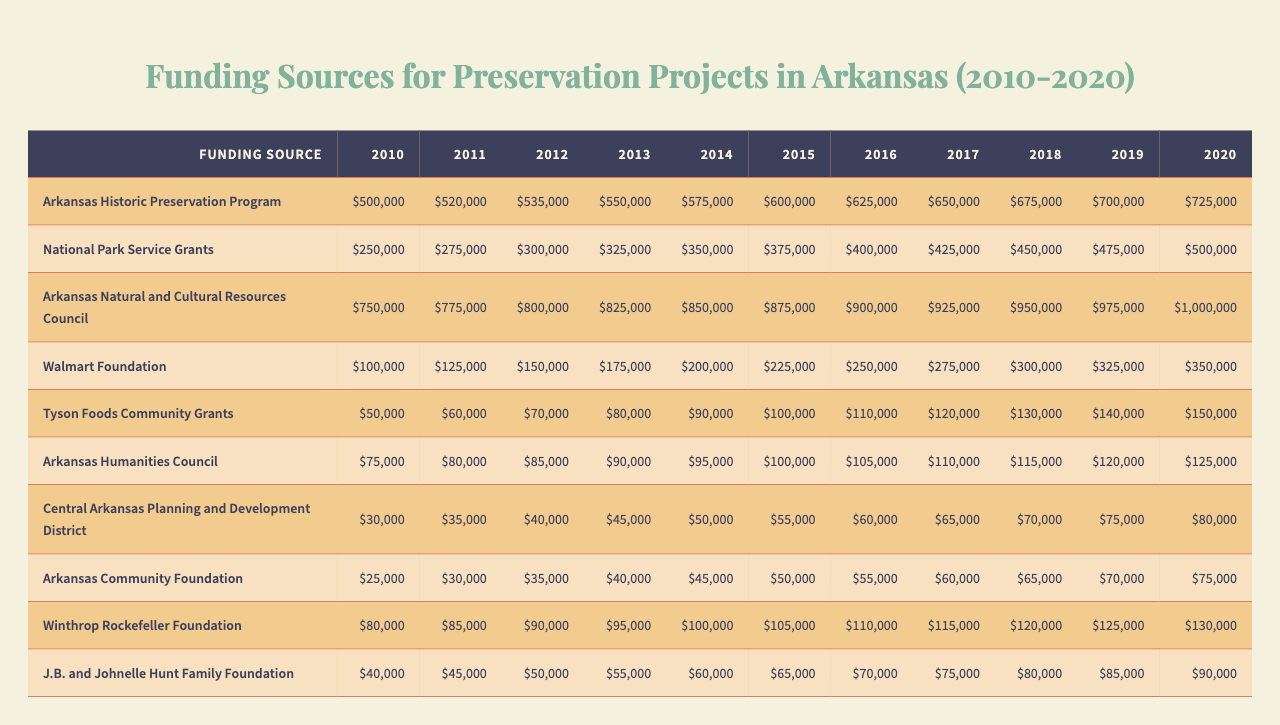What was the total funding from the Arkansas Natural and Cultural Resources Council in 2015? The funding amount from the Arkansas Natural and Cultural Resources Council for the year 2015 is listed in the table as $875,000.
Answer: $875,000 Which funding source had the highest amount in 2020? In 2020, the funding from the Arkansas Natural and Cultural Resources Council was the highest, with an amount of $1,000,000.
Answer: Arkansas Natural and Cultural Resources Council What is the difference in funding from the Walmart Foundation between 2010 and 2020? In 2010, the Walmart Foundation provided $100,000, and in 2020 it provided $350,000. The difference is $350,000 - $100,000 = $250,000.
Answer: $250,000 What was the average funding from the Arkansas Historic Preservation Program over the years 2010 to 2020? The total funding from the Arkansas Historic Preservation Program from 2010 to 2020 is 500,000 + 520,000 + 535,000 + 550,000 + 575,000 + 600,000 + 625,000 + 650,000 + 675,000 + 700,000 + 725,000 = $6,655,000. There are 11 years, so the average is $6,655,000 / 11 = $605,000.
Answer: $605,000 Did the funding from Tyson Foods Community Grants increase every year from 2010 to 2020? Yes, the table shows that the funding from Tyson Foods Community Grants started at $50,000 in 2010 and increased by $10,000 each year until reaching $150,000 in 2020.
Answer: Yes What was the total funding received from all sources in 2018? To find the total funding from all sources in 2018, we add the amounts: Arkansas Historic Preservation Program ($675,000) + National Park Service Grants ($450,000) + Arkansas Natural and Cultural Resources Council ($950,000) + Walmart Foundation ($300,000) + Tyson Foods Community Grants ($130,000) + Arkansas Humanities Council ($115,000) + Central Arkansas Planning and Development District ($70,000) + Arkansas Community Foundation ($65,000) + Winthrop Rockefeller Foundation ($120,000) + J.B. and Johnelle Hunt Family Foundation ($80,000) = $2,985,000.
Answer: $2,985,000 What years did the funding from the Central Arkansas Planning and Development District exceed $50,000? The amounts from the Central Arkansas Planning and Development District were $30,000 in 2010, $35,000 in 2011, $40,000 in 2012, $45,000 in 2013, $50,000 in 2014, $55,000 in 2015, $60,000 in 2016, $65,000 in 2017, $70,000 in 2018, $75,000 in 2019, and $80,000 in 2020. The years in which it exceeded $50,000 are 2015, 2016, 2017, 2018, 2019, and 2020.
Answer: 2015, 2016, 2017, 2018, 2019, 2020 What is the total funding increase from 2010 to 2020 for the Arkansas Community Foundation? The Arkansas Community Foundation started with $25,000 in 2010 and increased to $75,000 in 2020. The increase is $75,000 - $25,000 = $50,000.
Answer: $50,000 Which funding source showed the greatest percentage increase from 2010 to 2020? To find the percentage increase for each source, we calculate: ((final amount - initial amount) / initial amount) * 100. For the Arkansas Natural and Cultural Resources Council: ((1,000,000 - 750,000) / 750,000) * 100 = 33.33%. For others, the highest percentage increase is also for this source as all other sources had smaller increases.
Answer: Arkansas Natural and Cultural Resources Council What was the funding trend for the National Park Service Grants over the years? The National Park Service Grants showed a consistent increase in funding from $250,000 in 2010 to $500,000 in 2020, indicating a steady growth trend over the decade.
Answer: Steady increase 